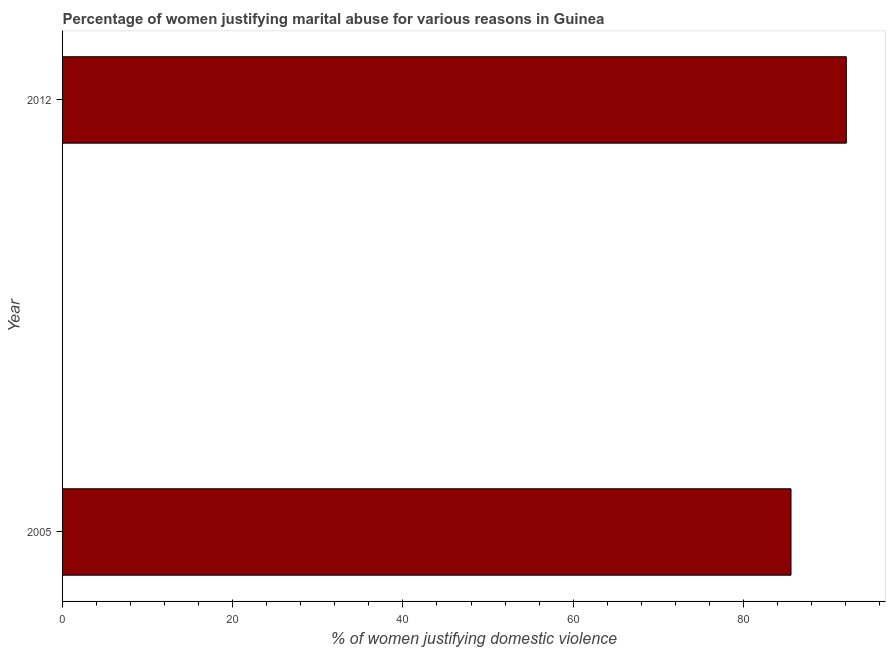Does the graph contain any zero values?
Provide a short and direct response. No. What is the title of the graph?
Keep it short and to the point. Percentage of women justifying marital abuse for various reasons in Guinea. What is the label or title of the X-axis?
Ensure brevity in your answer.  % of women justifying domestic violence. What is the percentage of women justifying marital abuse in 2005?
Offer a very short reply. 85.6. Across all years, what is the maximum percentage of women justifying marital abuse?
Provide a succinct answer. 92.1. Across all years, what is the minimum percentage of women justifying marital abuse?
Your answer should be compact. 85.6. In which year was the percentage of women justifying marital abuse minimum?
Your answer should be compact. 2005. What is the sum of the percentage of women justifying marital abuse?
Your answer should be compact. 177.7. What is the difference between the percentage of women justifying marital abuse in 2005 and 2012?
Your answer should be very brief. -6.5. What is the average percentage of women justifying marital abuse per year?
Offer a very short reply. 88.85. What is the median percentage of women justifying marital abuse?
Your answer should be compact. 88.85. In how many years, is the percentage of women justifying marital abuse greater than 48 %?
Give a very brief answer. 2. What is the ratio of the percentage of women justifying marital abuse in 2005 to that in 2012?
Provide a succinct answer. 0.93. Is the percentage of women justifying marital abuse in 2005 less than that in 2012?
Provide a succinct answer. Yes. How many bars are there?
Give a very brief answer. 2. How many years are there in the graph?
Your response must be concise. 2. What is the difference between two consecutive major ticks on the X-axis?
Your response must be concise. 20. Are the values on the major ticks of X-axis written in scientific E-notation?
Provide a short and direct response. No. What is the % of women justifying domestic violence of 2005?
Provide a succinct answer. 85.6. What is the % of women justifying domestic violence in 2012?
Offer a very short reply. 92.1. What is the difference between the % of women justifying domestic violence in 2005 and 2012?
Provide a short and direct response. -6.5. What is the ratio of the % of women justifying domestic violence in 2005 to that in 2012?
Provide a succinct answer. 0.93. 